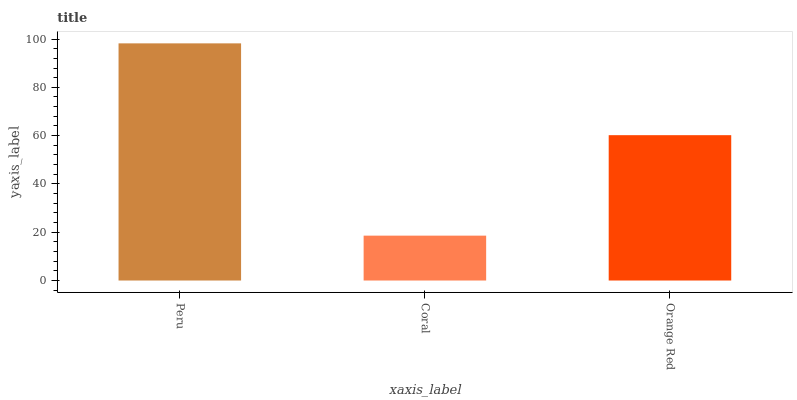Is Coral the minimum?
Answer yes or no. Yes. Is Peru the maximum?
Answer yes or no. Yes. Is Orange Red the minimum?
Answer yes or no. No. Is Orange Red the maximum?
Answer yes or no. No. Is Orange Red greater than Coral?
Answer yes or no. Yes. Is Coral less than Orange Red?
Answer yes or no. Yes. Is Coral greater than Orange Red?
Answer yes or no. No. Is Orange Red less than Coral?
Answer yes or no. No. Is Orange Red the high median?
Answer yes or no. Yes. Is Orange Red the low median?
Answer yes or no. Yes. Is Peru the high median?
Answer yes or no. No. Is Peru the low median?
Answer yes or no. No. 